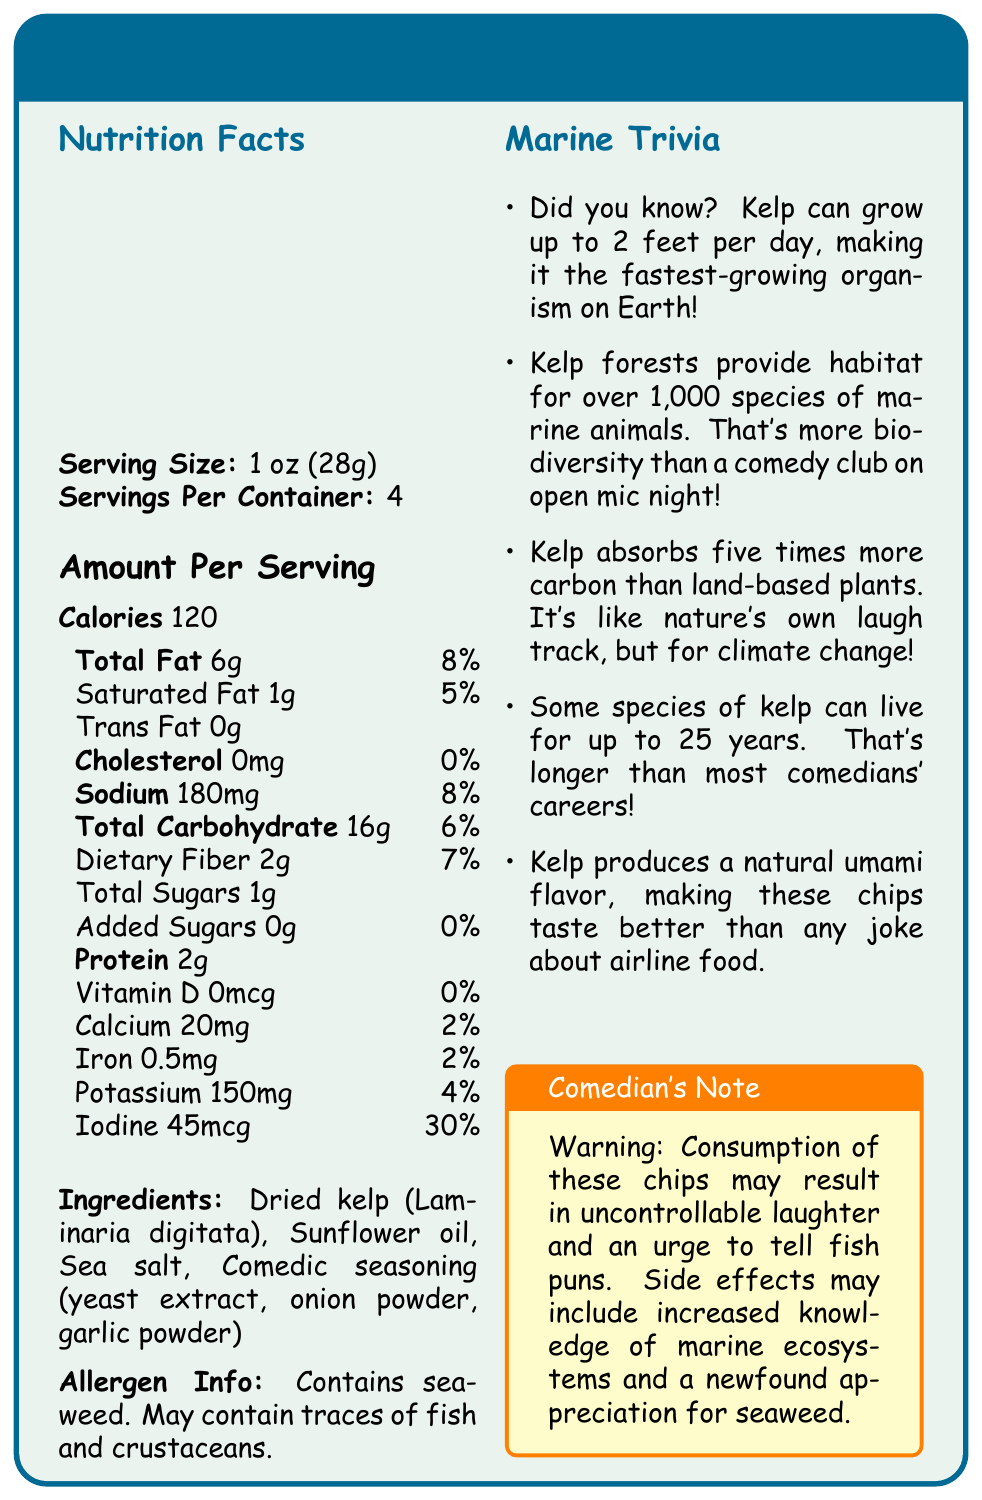what is the serving size for Laugh-out-loud Kelp Chips? The serving size is explicitly mentioned in the "Nutrition Facts" section of the document.
Answer: 1 oz (28g) how many calories are in one serving of Laugh-out-loud Kelp Chips? The calories per serving are listed under "Amount Per Serving" in the nutrition facts section.
Answer: 120 what is the amount of iodine per serving, and what percentage of Daily Value does it represent? The document states that the amount of iodine per serving is 45mcg, which accounts for 30% of the Daily Value.
Answer: 45mcg, 30% how many servings are there per container? The number of servings per container is clearly mentioned in the "Nutrition Facts" section.
Answer: 4 what are the main ingredients in Laugh-out-loud Kelp Chips? The ingredients are listed under the "Ingredients" section of the document.
Answer: Dried kelp (Laminaria digitata), Sunflower oil, Sea salt, Comedic seasoning (yeast extract, onion powder, garlic powder) which of the following nutrients is NOT present in Laugh-out-loud Kelp Chips?
A. Vitamin D
B. Cholesterol
C. Trans Fat
D. All of the above The document indicates that Vitamin D, Cholesterol, and Trans Fat are not present in the chips.
Answer: D. All of the above how much total fat is in one serving, and what is its percentage of the Daily Value? 
A. 4g, 5%
B. 6g, 8%
C. 1g, 5%
D. 0g, 0% The document states that one serving contains 6g of total fat, which is 8% of the Daily Value.
Answer: B. 6g, 8% are there any added sugars in Laugh-out-loud Kelp Chips? The "Nutrition Facts" section specifies that the amount of added sugars is 0g.
Answer: No is there any information about the environmental impact of kelp in the document? Under "Marine Trivia", it states that kelp absorbs five times more carbon than land-based plants, highlighting its positive environmental impact.
Answer: Yes summarize the main idea of the document. The document offers a comprehensive look at Laugh-out-loud Kelp Chips, including essential nutritional facts, ingredient lists, and fun trivia related to kelp, alongside a humorous touch.
Answer: The document provides nutritional information, ingredients, and allergen details for Laugh-out-loud Kelp Chips. It also includes marine trivia about kelp and a humorous comedian's note about the product. does the document mention the price of the Laugh-out-loud Kelp Chips? The document does not contain any information regarding the price of the Laugh-out-loud Kelp Chips.
Answer: Cannot be determined 